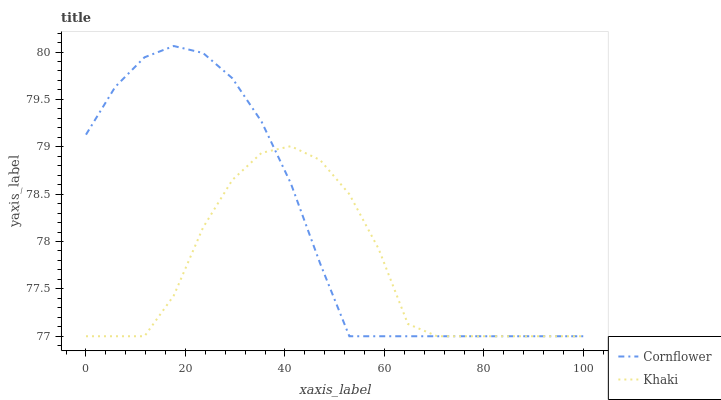Does Khaki have the maximum area under the curve?
Answer yes or no. No. Is Khaki the smoothest?
Answer yes or no. No. Does Khaki have the highest value?
Answer yes or no. No. 